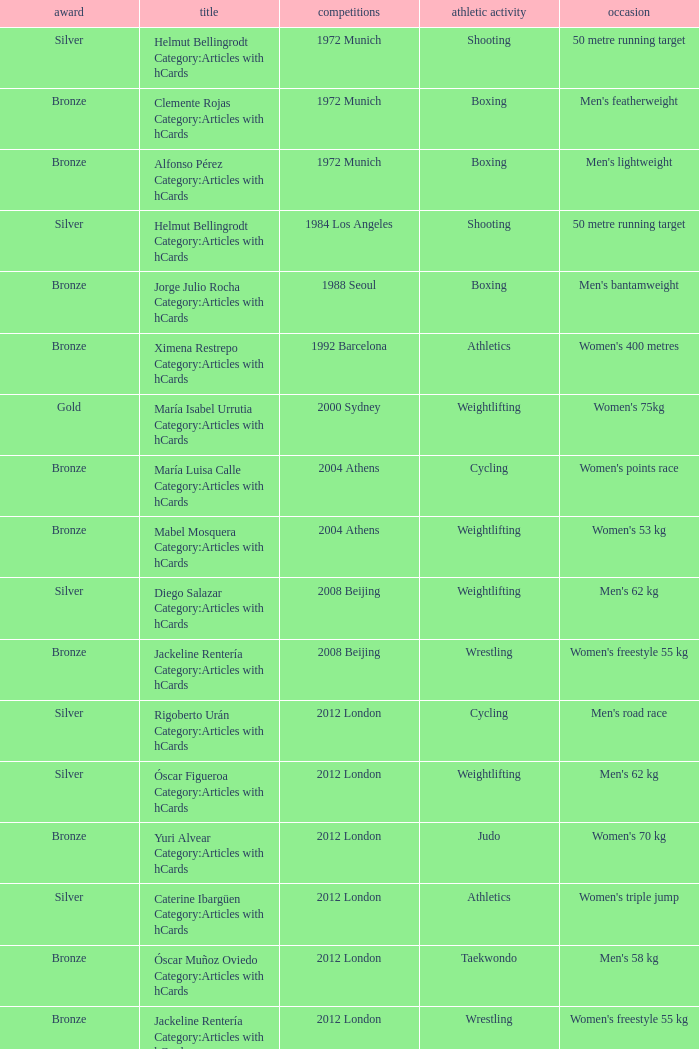Which wrestling event was at the 2008 Beijing games? Women's freestyle 55 kg. 